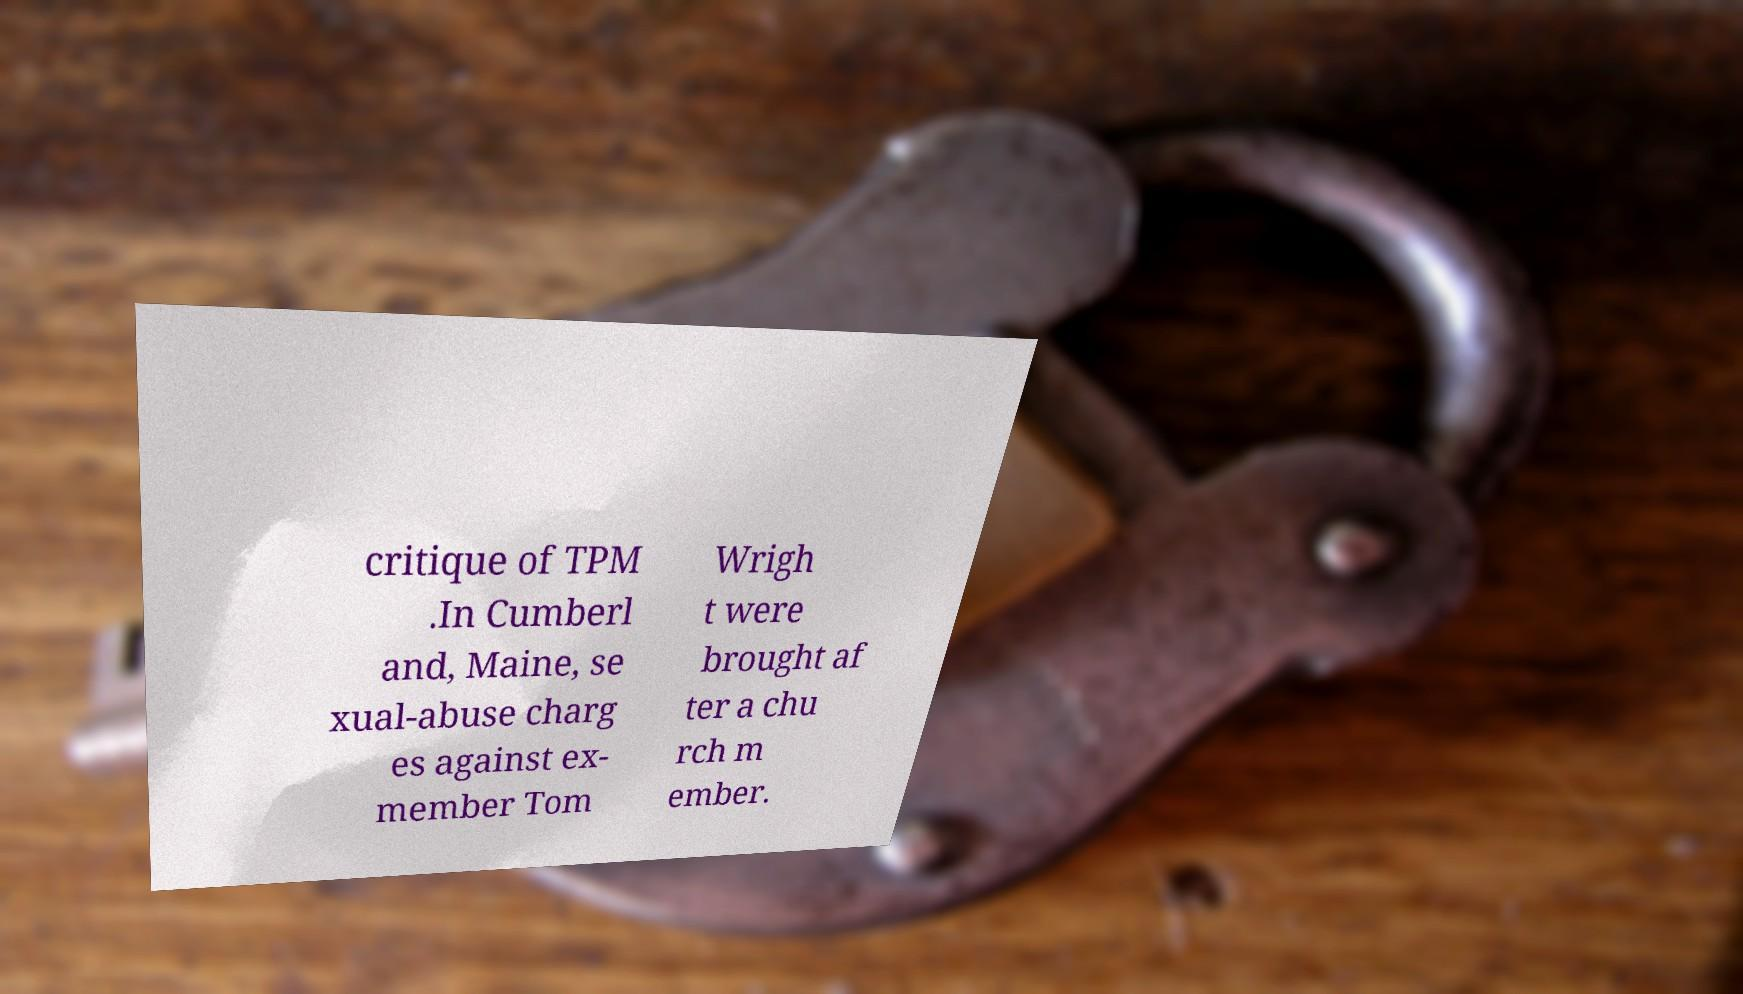I need the written content from this picture converted into text. Can you do that? critique of TPM .In Cumberl and, Maine, se xual-abuse charg es against ex- member Tom Wrigh t were brought af ter a chu rch m ember. 